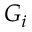Convert formula to latex. <formula><loc_0><loc_0><loc_500><loc_500>G _ { i }</formula> 